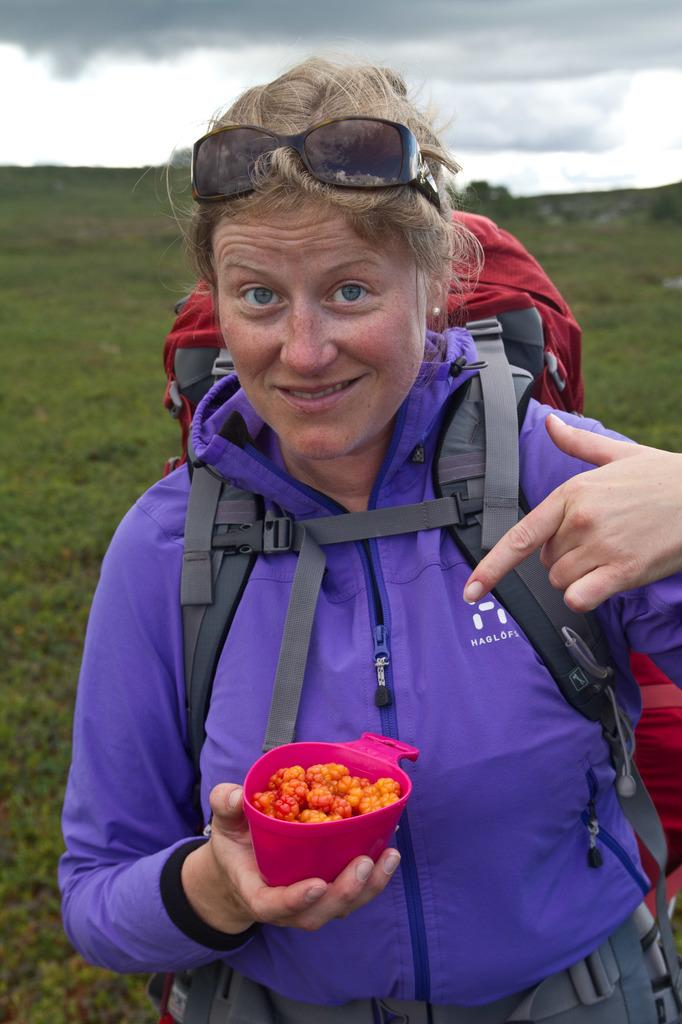What is present in the image? There is a person in the image. What is the person holding? The person is holding a food item. What can be seen in the background of the image? The sky is visible in the background of the image. Is the person in the image currently serving a prison sentence? There is no information in the image to suggest that the person is in prison or serving a sentence. 